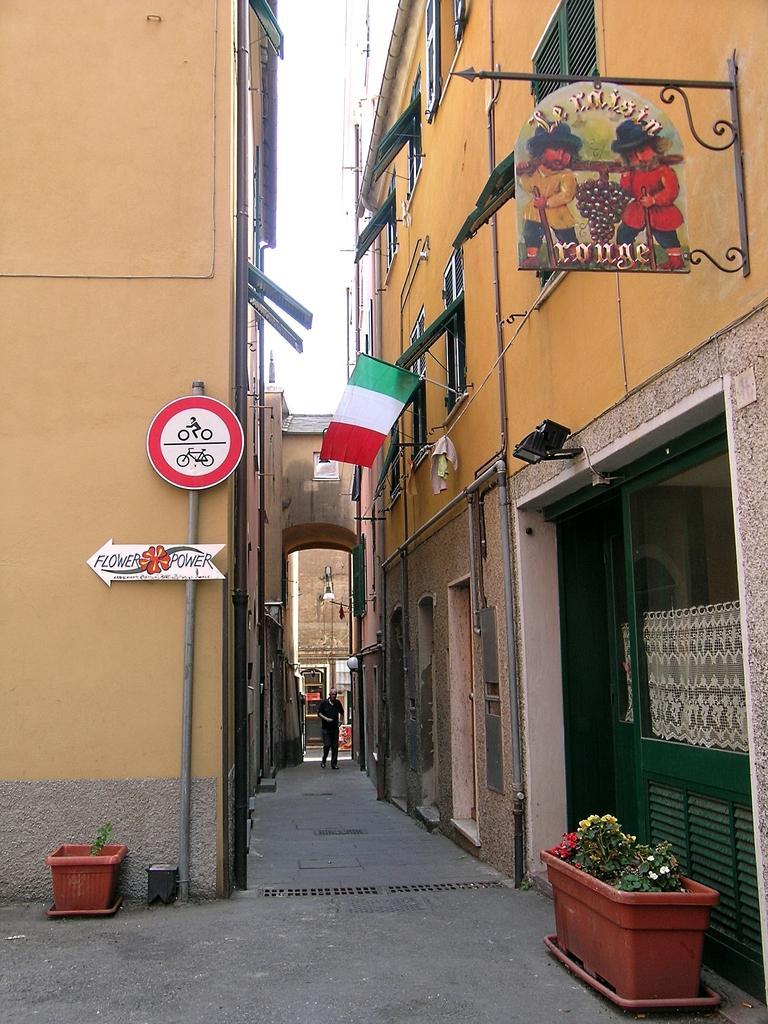Describe this image in one or two sentences. In the foreground of this image, there is a path, few flower pots and boards. On either side, there are buildings and in the middle, there is an arch. At the top, there is the sky. 